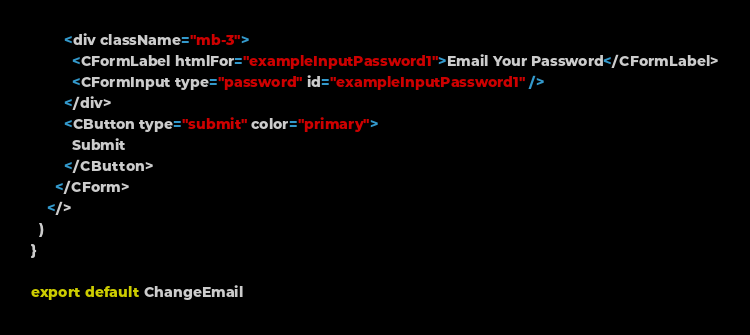Convert code to text. <code><loc_0><loc_0><loc_500><loc_500><_JavaScript_>        <div className="mb-3">
          <CFormLabel htmlFor="exampleInputPassword1">Email Your Password</CFormLabel>
          <CFormInput type="password" id="exampleInputPassword1" />
        </div>
        <CButton type="submit" color="primary">
          Submit
        </CButton>
      </CForm>
    </>
  )
}

export default ChangeEmail
</code> 